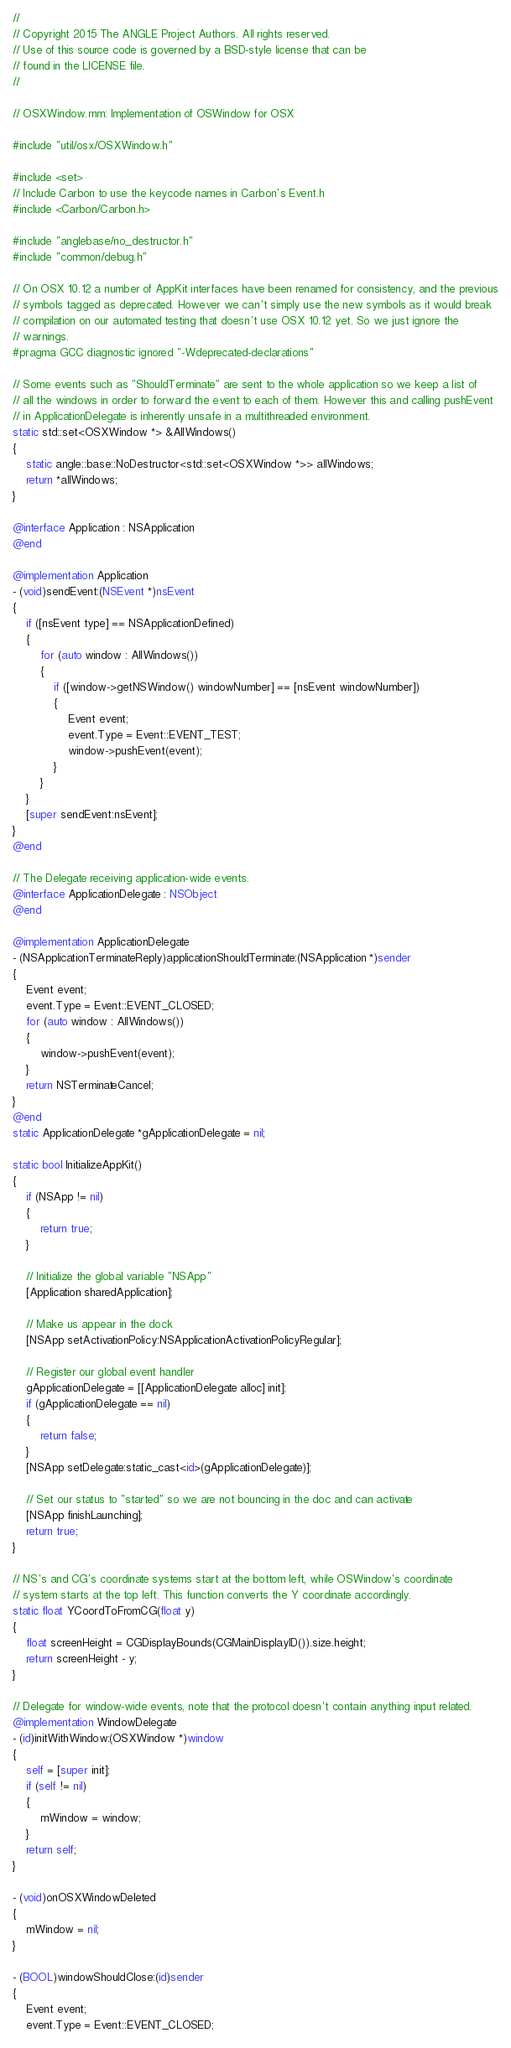Convert code to text. <code><loc_0><loc_0><loc_500><loc_500><_ObjectiveC_>//
// Copyright 2015 The ANGLE Project Authors. All rights reserved.
// Use of this source code is governed by a BSD-style license that can be
// found in the LICENSE file.
//

// OSXWindow.mm: Implementation of OSWindow for OSX

#include "util/osx/OSXWindow.h"

#include <set>
// Include Carbon to use the keycode names in Carbon's Event.h
#include <Carbon/Carbon.h>

#include "anglebase/no_destructor.h"
#include "common/debug.h"

// On OSX 10.12 a number of AppKit interfaces have been renamed for consistency, and the previous
// symbols tagged as deprecated. However we can't simply use the new symbols as it would break
// compilation on our automated testing that doesn't use OSX 10.12 yet. So we just ignore the
// warnings.
#pragma GCC diagnostic ignored "-Wdeprecated-declarations"

// Some events such as "ShouldTerminate" are sent to the whole application so we keep a list of
// all the windows in order to forward the event to each of them. However this and calling pushEvent
// in ApplicationDelegate is inherently unsafe in a multithreaded environment.
static std::set<OSXWindow *> &AllWindows()
{
    static angle::base::NoDestructor<std::set<OSXWindow *>> allWindows;
    return *allWindows;
}

@interface Application : NSApplication
@end

@implementation Application
- (void)sendEvent:(NSEvent *)nsEvent
{
    if ([nsEvent type] == NSApplicationDefined)
    {
        for (auto window : AllWindows())
        {
            if ([window->getNSWindow() windowNumber] == [nsEvent windowNumber])
            {
                Event event;
                event.Type = Event::EVENT_TEST;
                window->pushEvent(event);
            }
        }
    }
    [super sendEvent:nsEvent];
}
@end

// The Delegate receiving application-wide events.
@interface ApplicationDelegate : NSObject
@end

@implementation ApplicationDelegate
- (NSApplicationTerminateReply)applicationShouldTerminate:(NSApplication *)sender
{
    Event event;
    event.Type = Event::EVENT_CLOSED;
    for (auto window : AllWindows())
    {
        window->pushEvent(event);
    }
    return NSTerminateCancel;
}
@end
static ApplicationDelegate *gApplicationDelegate = nil;

static bool InitializeAppKit()
{
    if (NSApp != nil)
    {
        return true;
    }

    // Initialize the global variable "NSApp"
    [Application sharedApplication];

    // Make us appear in the dock
    [NSApp setActivationPolicy:NSApplicationActivationPolicyRegular];

    // Register our global event handler
    gApplicationDelegate = [[ApplicationDelegate alloc] init];
    if (gApplicationDelegate == nil)
    {
        return false;
    }
    [NSApp setDelegate:static_cast<id>(gApplicationDelegate)];

    // Set our status to "started" so we are not bouncing in the doc and can activate
    [NSApp finishLaunching];
    return true;
}

// NS's and CG's coordinate systems start at the bottom left, while OSWindow's coordinate
// system starts at the top left. This function converts the Y coordinate accordingly.
static float YCoordToFromCG(float y)
{
    float screenHeight = CGDisplayBounds(CGMainDisplayID()).size.height;
    return screenHeight - y;
}

// Delegate for window-wide events, note that the protocol doesn't contain anything input related.
@implementation WindowDelegate
- (id)initWithWindow:(OSXWindow *)window
{
    self = [super init];
    if (self != nil)
    {
        mWindow = window;
    }
    return self;
}

- (void)onOSXWindowDeleted
{
    mWindow = nil;
}

- (BOOL)windowShouldClose:(id)sender
{
    Event event;
    event.Type = Event::EVENT_CLOSED;</code> 